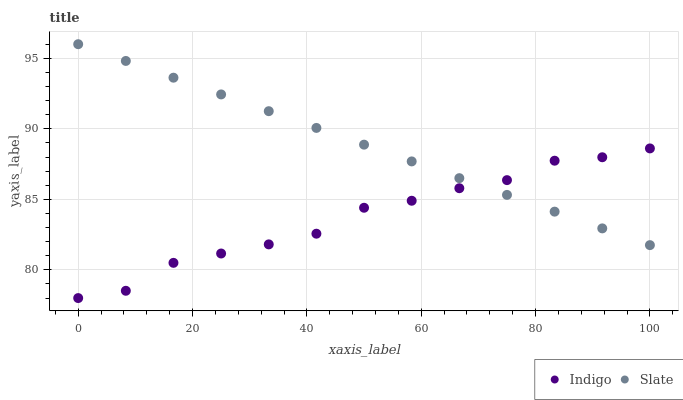Does Indigo have the minimum area under the curve?
Answer yes or no. Yes. Does Slate have the maximum area under the curve?
Answer yes or no. Yes. Does Indigo have the maximum area under the curve?
Answer yes or no. No. Is Slate the smoothest?
Answer yes or no. Yes. Is Indigo the roughest?
Answer yes or no. Yes. Is Indigo the smoothest?
Answer yes or no. No. Does Indigo have the lowest value?
Answer yes or no. Yes. Does Slate have the highest value?
Answer yes or no. Yes. Does Indigo have the highest value?
Answer yes or no. No. Does Indigo intersect Slate?
Answer yes or no. Yes. Is Indigo less than Slate?
Answer yes or no. No. Is Indigo greater than Slate?
Answer yes or no. No. 